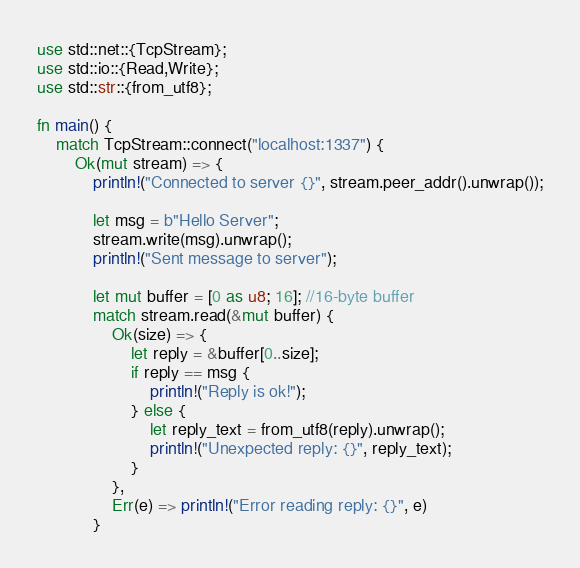<code> <loc_0><loc_0><loc_500><loc_500><_Rust_>use std::net::{TcpStream};
use std::io::{Read,Write};
use std::str::{from_utf8};

fn main() {
    match TcpStream::connect("localhost:1337") {
        Ok(mut stream) => {
            println!("Connected to server {}", stream.peer_addr().unwrap());

            let msg = b"Hello Server";
            stream.write(msg).unwrap();
            println!("Sent message to server");

            let mut buffer = [0 as u8; 16]; //16-byte buffer
            match stream.read(&mut buffer) {
                Ok(size) => {
                    let reply = &buffer[0..size];
                    if reply == msg {
                        println!("Reply is ok!");
                    } else {
                        let reply_text = from_utf8(reply).unwrap();
                        println!("Unexpected reply: {}", reply_text);
                    }
                },
                Err(e) => println!("Error reading reply: {}", e)
            }</code> 